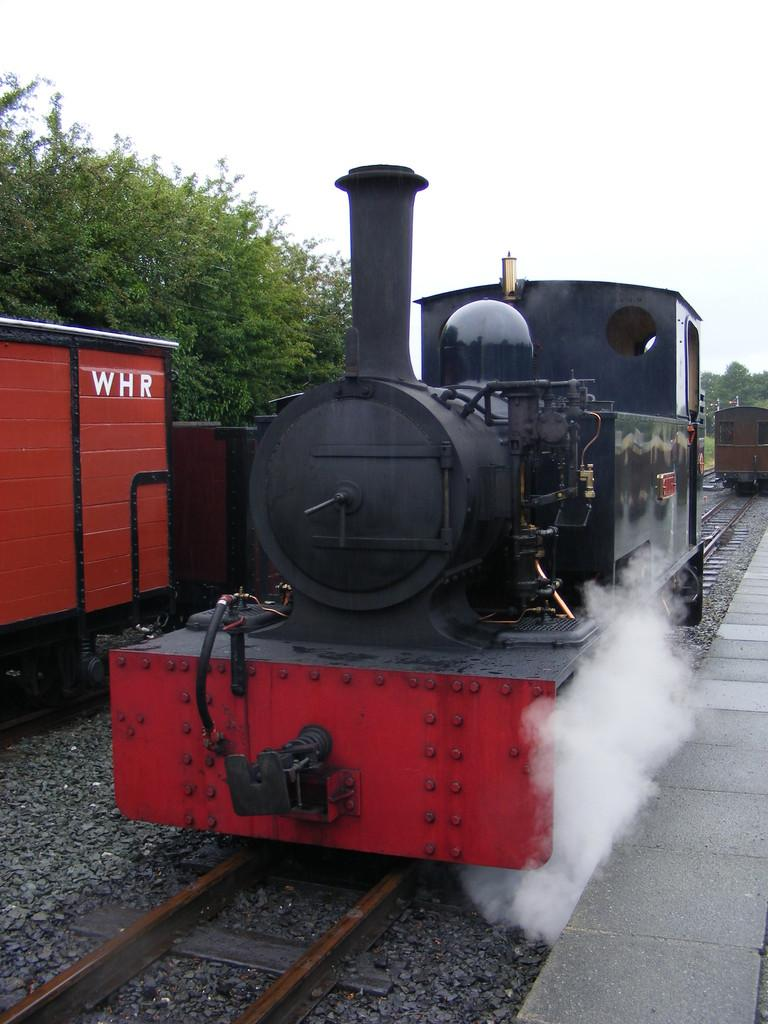What is the main subject of the image? The main subject of the image is a train engine. Where is the train engine located in the image? The train engine is placed on a track. What can be seen in the background of the image? There are wagons, a group of trees, and the sky visible in the background of the image. What type of quiver is attached to the train engine in the image? There is no quiver present on the train engine in the image. Can you point out the building in the image? There is no building present in the image; it features a train engine, wagons, trees, and the sky. 